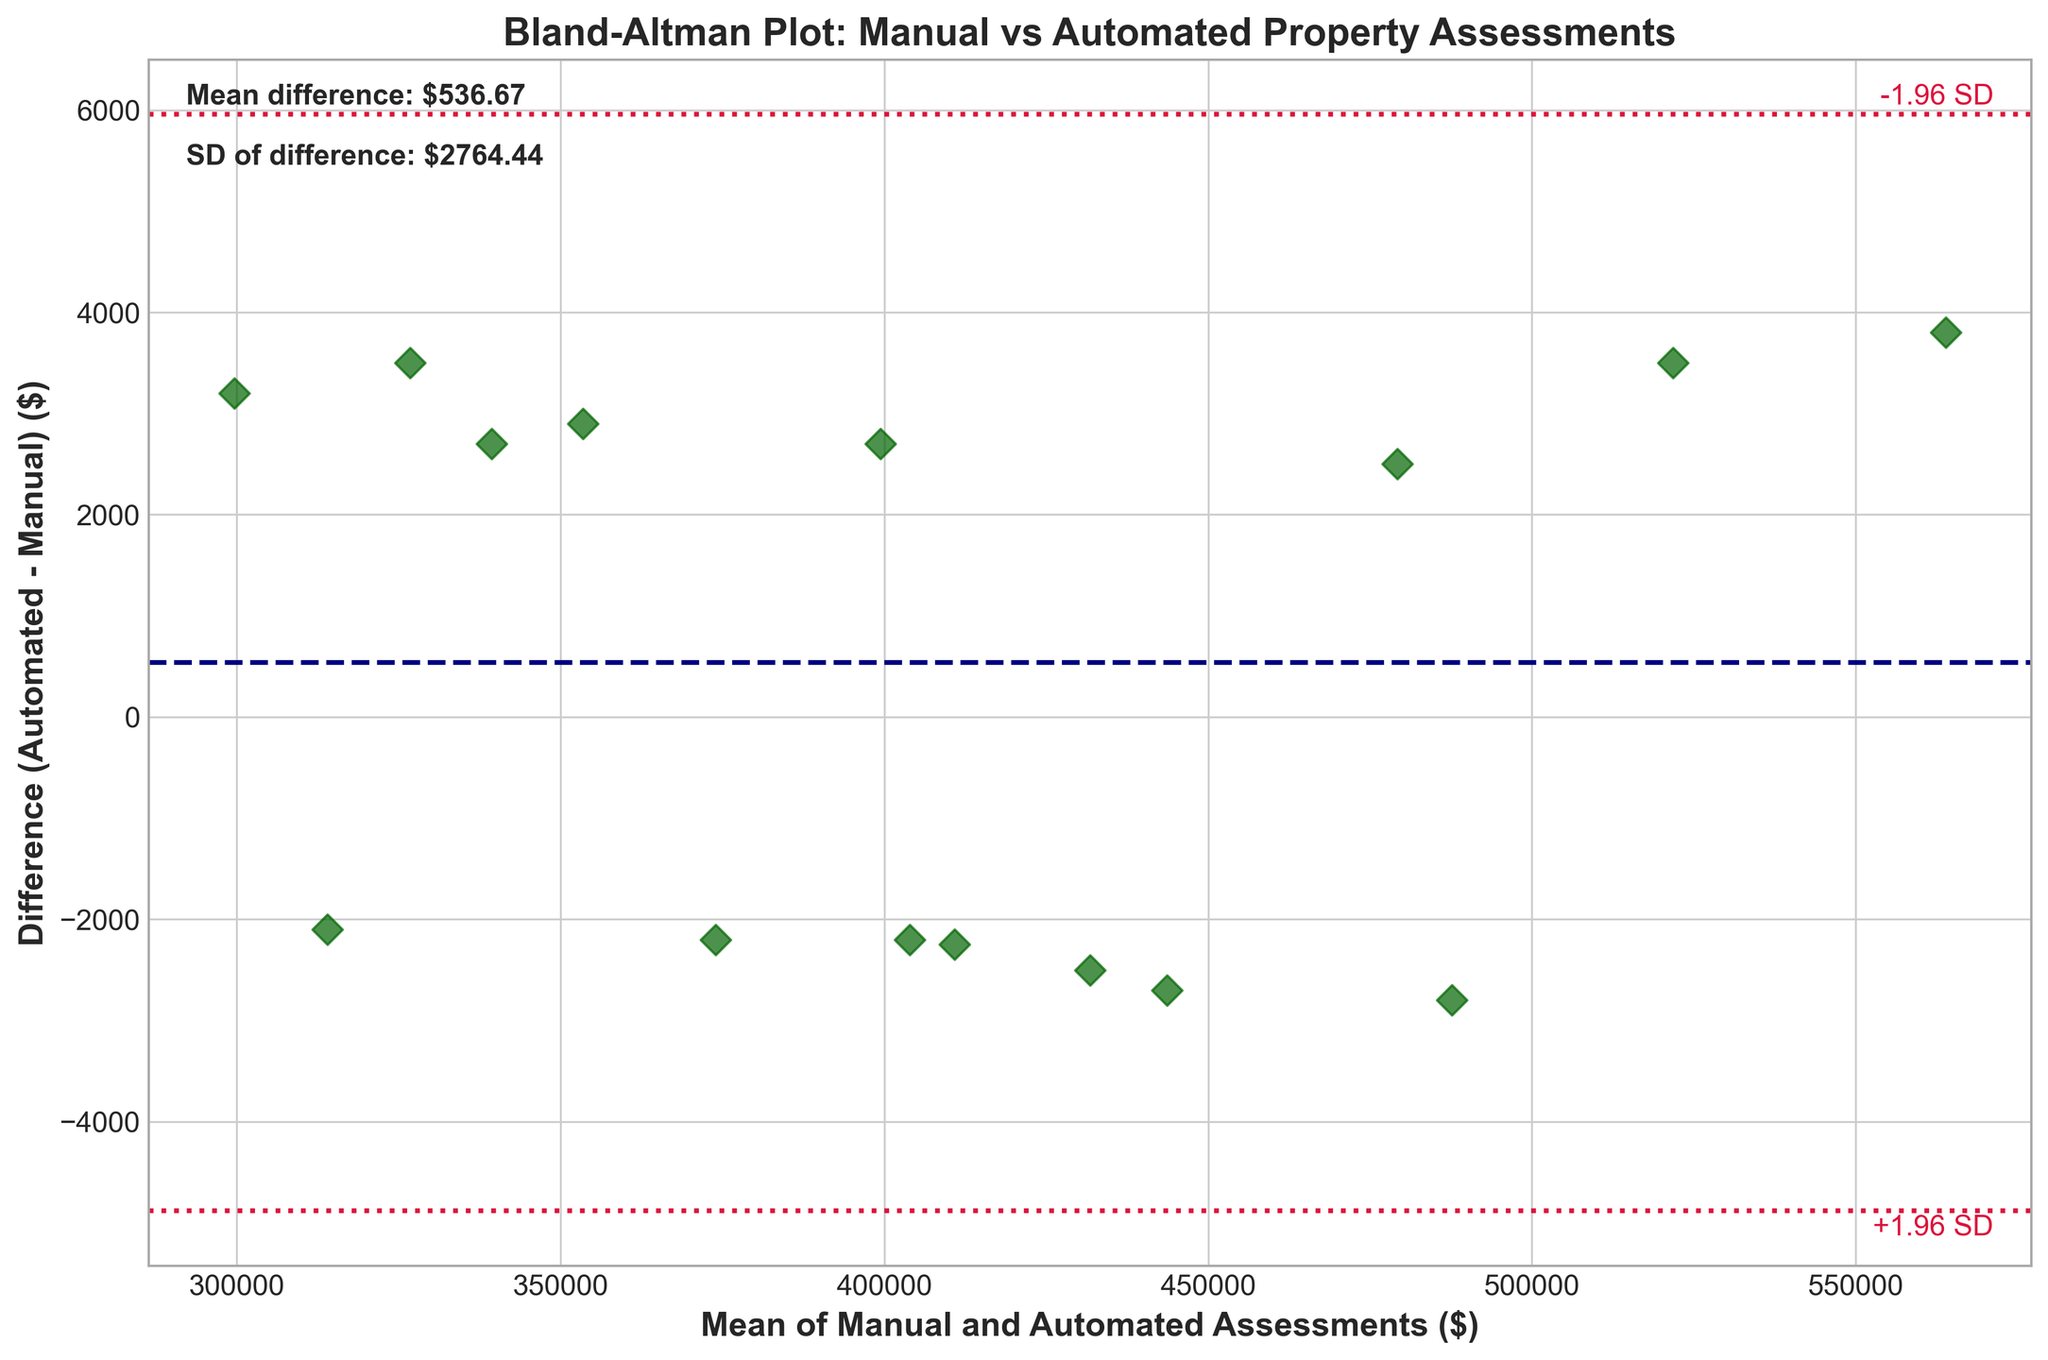What is the title of the plot? The title of the plot is located at the top center. By reading it, you can see that it states "Bland-Altman Plot: Manual vs Automated Property Assessments".
Answer: Bland-Altman Plot: Manual vs Automated Property Assessments What does the x-axis represent? The x-axis is labeled, showing that it represents the "Mean of Manual and Automated Assessments ($)".
Answer: Mean of Manual and Automated Assessments ($) What does the y-axis represent? The y-axis is labeled, showing that it represents the "Difference (Automated - Manual) ($)".
Answer: Difference (Automated - Manual) ($) How many data points are plotted? By counting the number of diamond markers (D) on the plot, you can see there are 15 data points.
Answer: 15 What color are the data points in the plot? By observing the color of the diamond markers, you will see that they are dark green.
Answer: Dark green What is the mean difference between automated and manual assessments? There is a text annotation on the top left of the plot that indicates the mean difference is $-274.53.
Answer: -274.53 What are the upper and lower 1.96 standard deviation limits? The text annotations indicate the limits: the upper limit ("+1.96 SD") of $4764.48 and the lower limit ("-1.96 SD") of $-5313.54.
Answer: +4764.48 and -5313.54 What trend can you see from the scatter plot regarding the differences in assessments? The plot shows most data points are close to the mean difference line, with random dispersion. This suggests no systematic bias but random variations.
Answer: Random variations around the mean Which property has the largest difference in assessments? By examining the plot, the property with the largest positive deviation from the mean line is visually noticeable. However, without specific property labels, we can't identify it directly from the plot alone.
Answer: Unable to determine from plot Are the differences between manual and automated assessments more likely negative or positive? The mean difference is negative ($-274.53), indicating that on average, automated assessments tend to be slightly less than manual ones.
Answer: More likely negative 